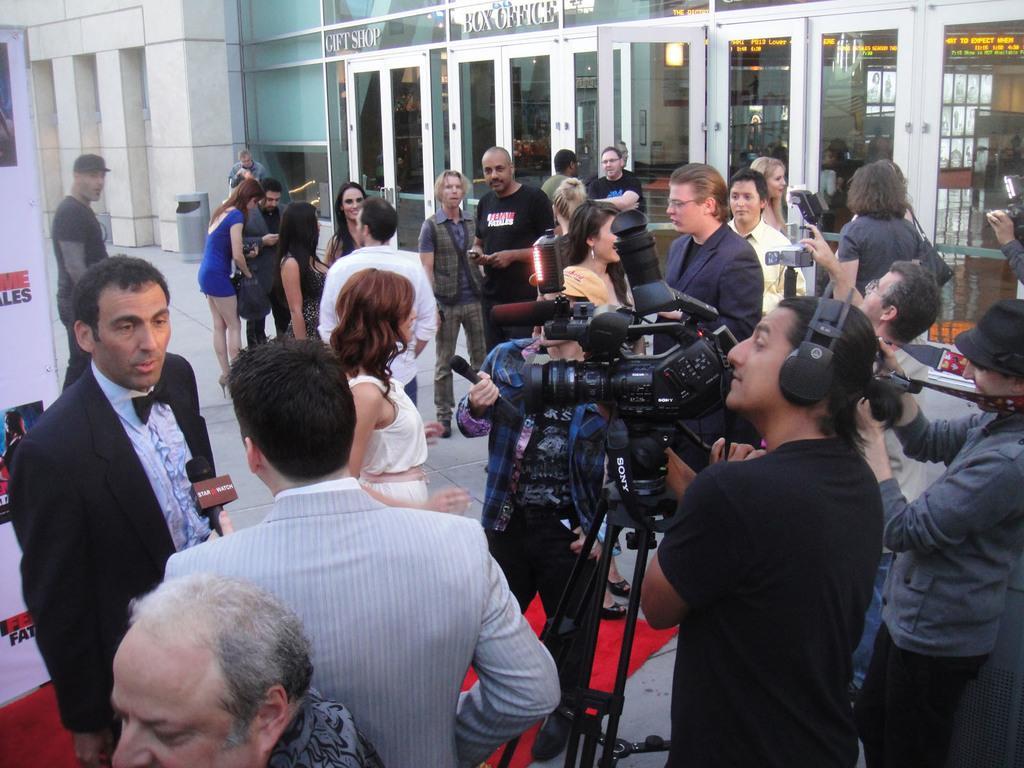Please provide a concise description of this image. In this image it seems like there are reporters who are interviewing the people. In the middle there is a cameraman who is taking the video. In the background it looks like it is a theater. On the left side there is a banner. At the bottom there is a red carpet. There are so many people in the middle. 